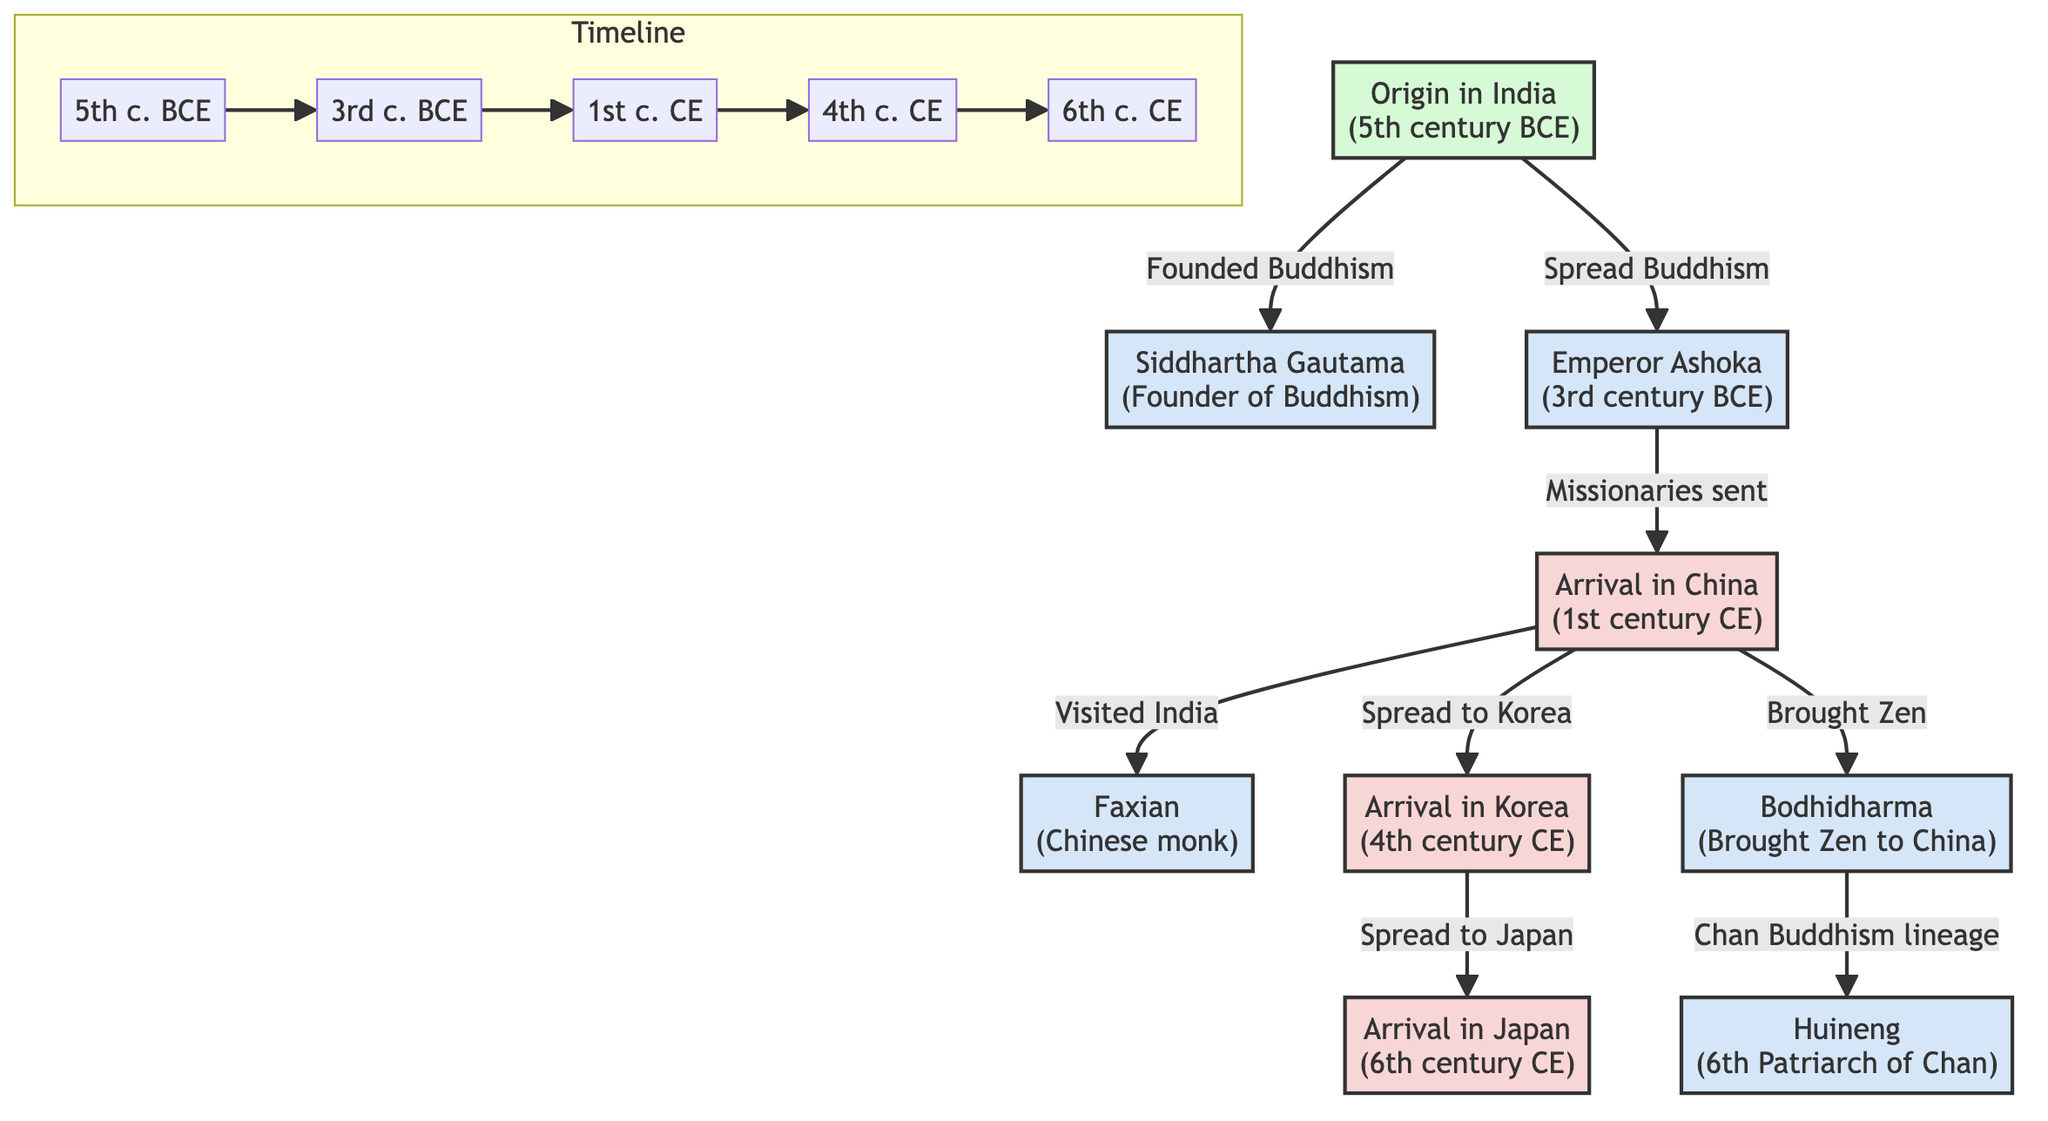What is the origin of Buddhism? The diagram indicates that Buddhism originated in India during the 5th century BCE, as shown in the first event node labeled "Origin in India."
Answer: India Who was the founder of Buddhism? The diagram identifies Siddhartha Gautama as the founder of Buddhism in the node directly connected to the origin event, thus establishing his role clearly.
Answer: Siddhartha Gautama In which century did Buddhism arrive in Korea? According to the timeline within the diagram, Buddhism arrived in Korea during the 4th century CE, which is indicated by the connection from the China node.
Answer: 4th century CE Which Emperor played a key role in spreading Buddhism to other regions? The diagram highlights Emperor Ashoka as a significant figure who spread Buddhism, as indicated in the flow from the "Spread Buddhism" action connected to him.
Answer: Emperor Ashoka What lineage did Bodhidharma contribute to in China? The diagram illustrates that Bodhidharma brought Zen to China, and he is noted as a pivotal figure leading to the Chan Buddhism lineage, ultimately linked to Huineng.
Answer: Chan Buddhism lineage How did Buddhism spread from India to China? According to the diagram, Ashoka sent missionaries to China, which is depicted in the direct connection between his node and the node representing China.
Answer: Missionaries Who visited India as a Chinese monk to learn Buddhism? The diagram specifies Faxian as the Chinese monk who visited India, linked directly to the China node indicating a flow of knowledge and pilgrimage.
Answer: Faxian Which figure is identified as the 6th Patriarch of Chan? The diagram names Huineng as the 6th Patriarch of Chan, which is shown through the connection from Bodhidharma, illustrating the succession in the Zen lineage.
Answer: Huineng What is the relationship between the arrival of Buddhism in Japan and Korea? The diagram describes the arrival in Japan as a subsequent event that occurred after the spread of Buddhism to Korea, indicating a direct lineage from Korea to Japan.
Answer: Spread to Japan What was the timeframe for the origin of Buddhism? The origin of Buddhism is placed in the 5th century BCE according to the diagram, which is explicitly indicated in the timeline and event node.
Answer: 5th century BCE 